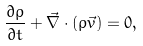Convert formula to latex. <formula><loc_0><loc_0><loc_500><loc_500>\frac { \partial \rho } { \partial t } + \vec { \nabla } \cdot ( \rho \vec { v } ) = 0 ,</formula> 